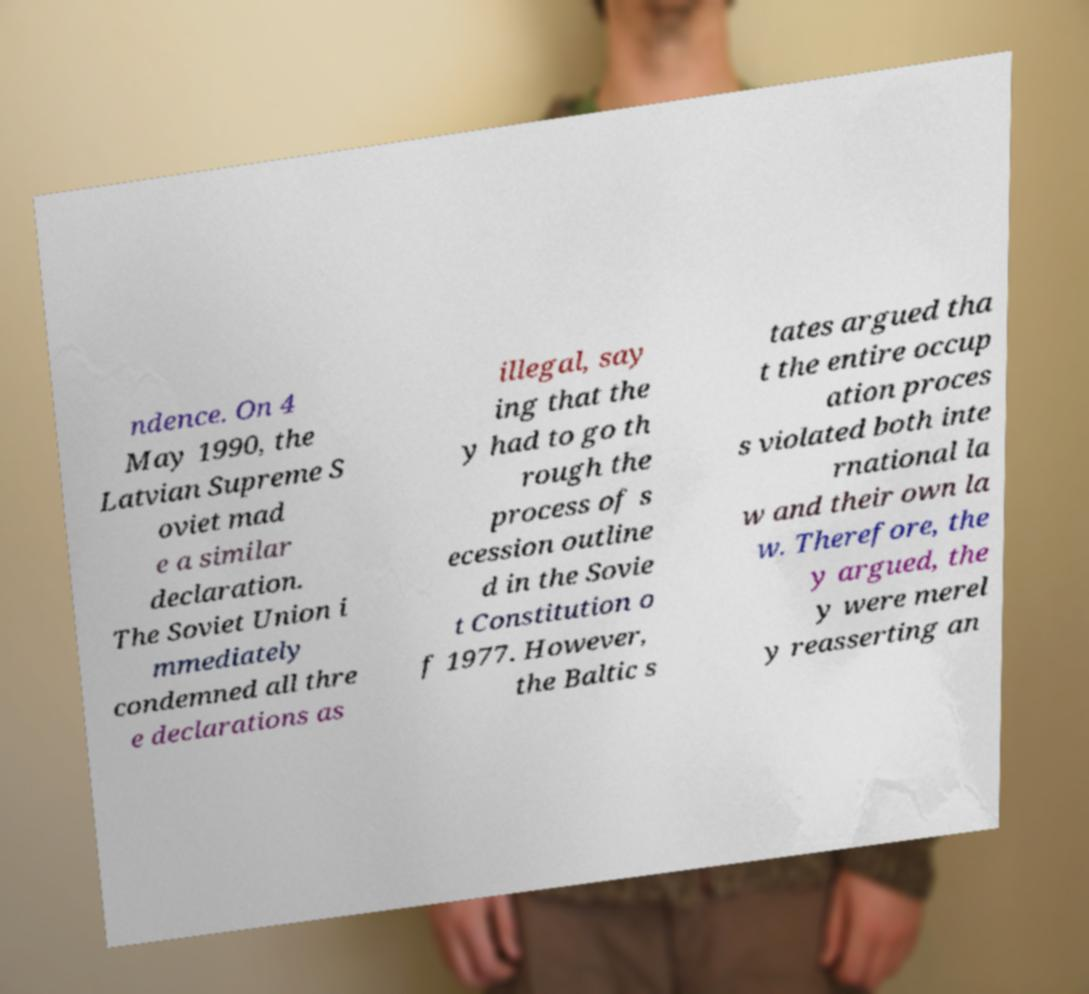Please read and relay the text visible in this image. What does it say? ndence. On 4 May 1990, the Latvian Supreme S oviet mad e a similar declaration. The Soviet Union i mmediately condemned all thre e declarations as illegal, say ing that the y had to go th rough the process of s ecession outline d in the Sovie t Constitution o f 1977. However, the Baltic s tates argued tha t the entire occup ation proces s violated both inte rnational la w and their own la w. Therefore, the y argued, the y were merel y reasserting an 